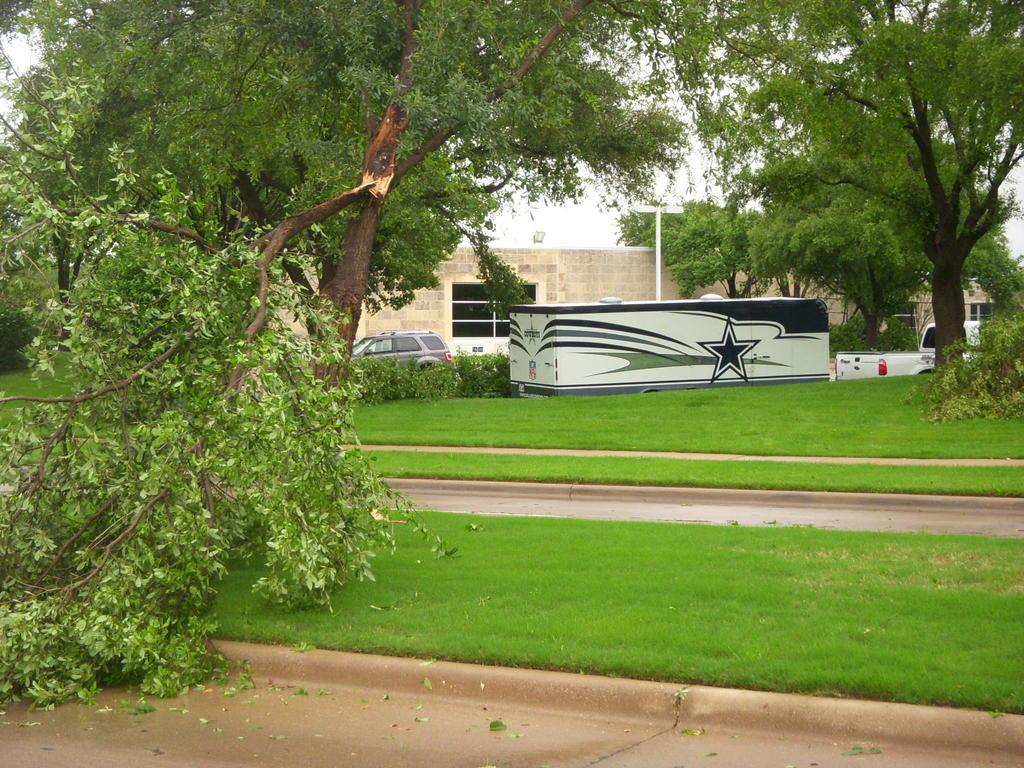What type of vegetation can be seen in the image? There are trees in the image. What is located in front of the building? There are vehicles in front of a building. What is the path in the image made of? The path in the image is between grass. What is in the middle of the image? There is a pole and plants in the middle of the image. What shape is the throat of the person in the image? There is no person present in the image, so we cannot determine the shape of their throat. 